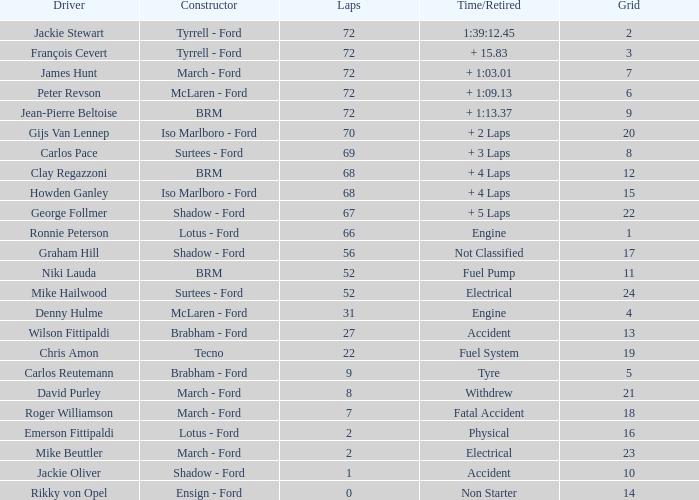Which lap had the highest tire time? 9.0. 